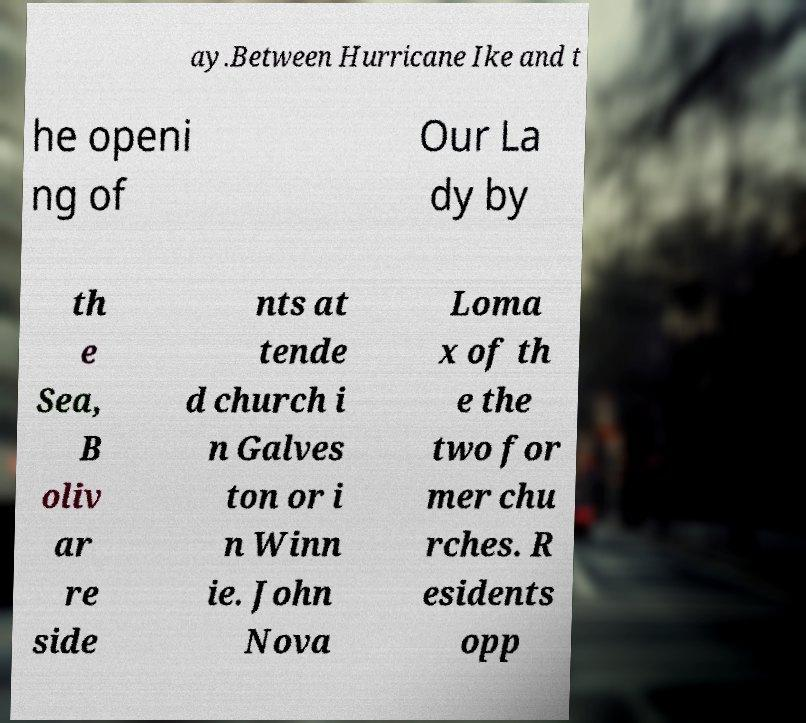Can you accurately transcribe the text from the provided image for me? ay.Between Hurricane Ike and t he openi ng of Our La dy by th e Sea, B oliv ar re side nts at tende d church i n Galves ton or i n Winn ie. John Nova Loma x of th e the two for mer chu rches. R esidents opp 